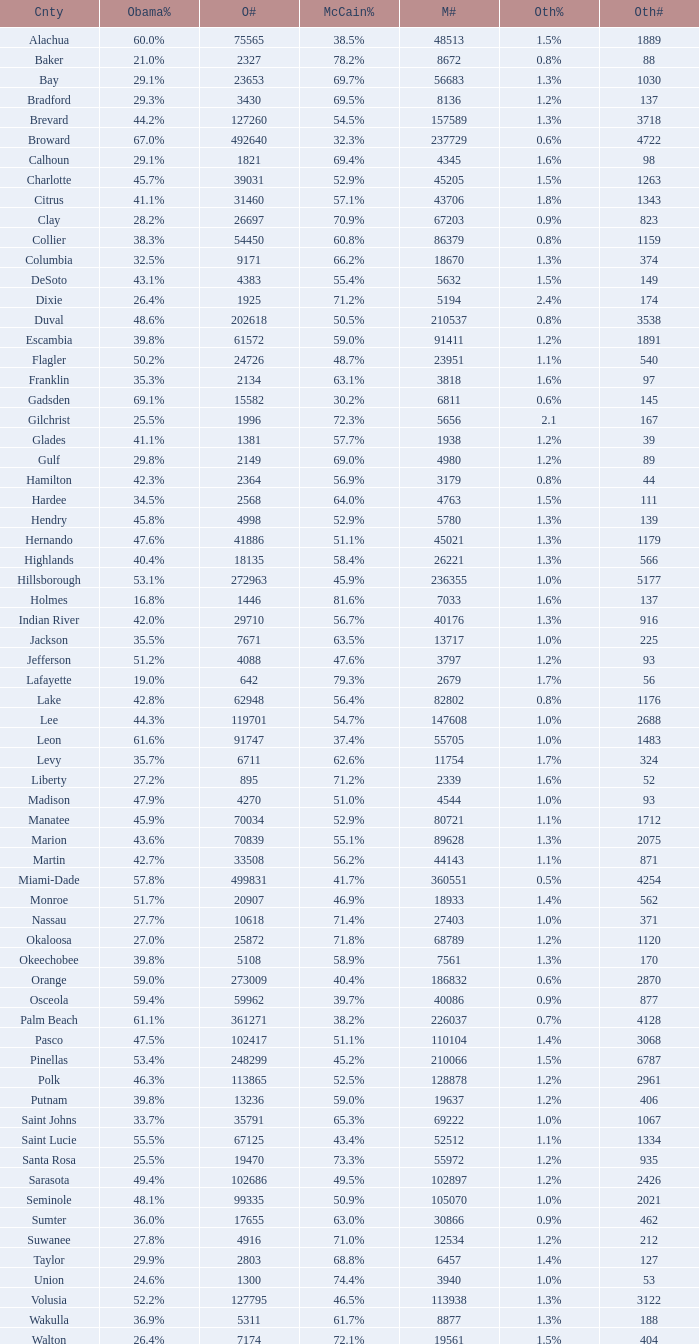What percentage was the others vote when McCain had 52.9% and less than 45205.0 voters? 1.3%. 